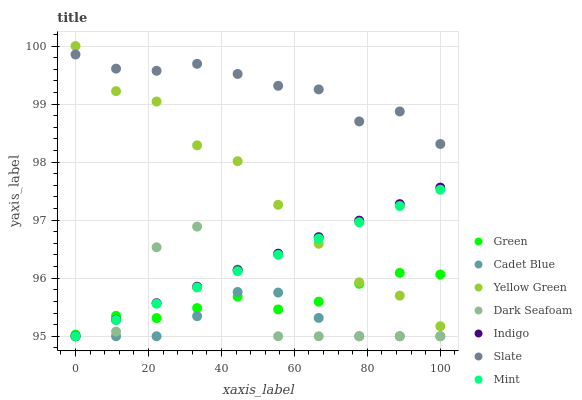Does Cadet Blue have the minimum area under the curve?
Answer yes or no. Yes. Does Slate have the maximum area under the curve?
Answer yes or no. Yes. Does Indigo have the minimum area under the curve?
Answer yes or no. No. Does Indigo have the maximum area under the curve?
Answer yes or no. No. Is Indigo the smoothest?
Answer yes or no. Yes. Is Dark Seafoam the roughest?
Answer yes or no. Yes. Is Yellow Green the smoothest?
Answer yes or no. No. Is Yellow Green the roughest?
Answer yes or no. No. Does Cadet Blue have the lowest value?
Answer yes or no. Yes. Does Yellow Green have the lowest value?
Answer yes or no. No. Does Yellow Green have the highest value?
Answer yes or no. Yes. Does Indigo have the highest value?
Answer yes or no. No. Is Green less than Slate?
Answer yes or no. Yes. Is Yellow Green greater than Dark Seafoam?
Answer yes or no. Yes. Does Indigo intersect Dark Seafoam?
Answer yes or no. Yes. Is Indigo less than Dark Seafoam?
Answer yes or no. No. Is Indigo greater than Dark Seafoam?
Answer yes or no. No. Does Green intersect Slate?
Answer yes or no. No. 